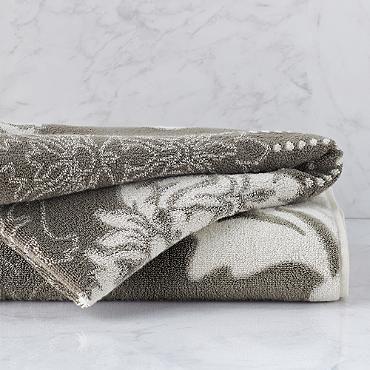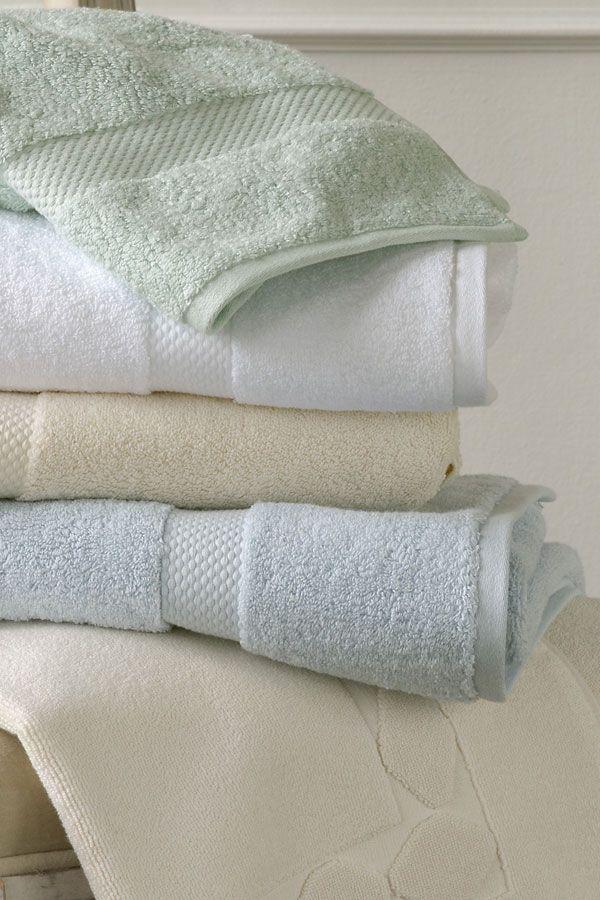The first image is the image on the left, the second image is the image on the right. For the images shown, is this caption "One image includes gray and white towels with an all-over pattern." true? Answer yes or no. Yes. 